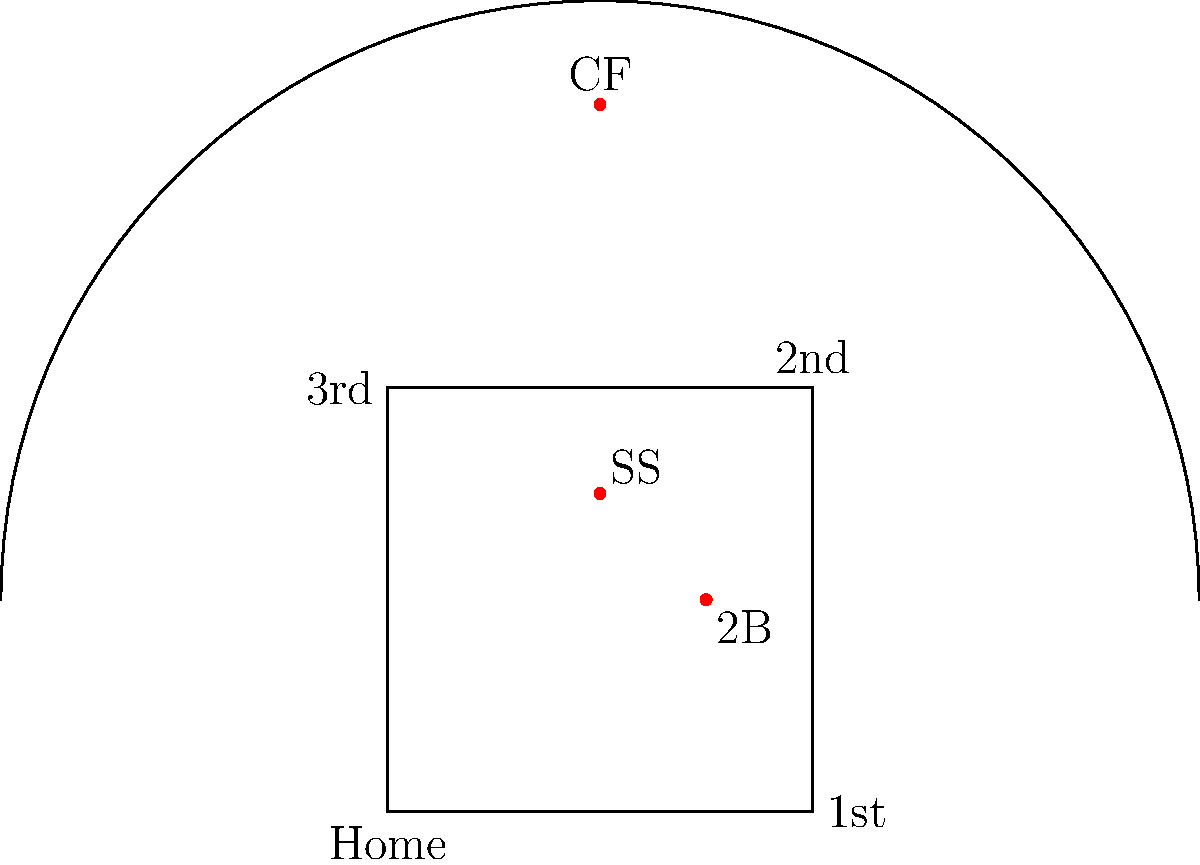Based on the baseball field diagram, which fielder position is best suited to cover the gap between second base and shortstop, while also providing support for shallow outfield plays? To answer this question, we need to analyze the positions of the fielders shown in the diagram and their strategic placement on the field:

1. The diagram shows three key defensive positions: shortstop (SS), second base (2B), and center field (CF).

2. The shortstop is positioned between second and third base, slightly closer to third.

3. The second baseman is positioned between first and second base, slightly closer to first.

4. The center fielder is positioned deep in the outfield, directly behind second base.

5. The gap between second base and shortstop is a common area for ground balls and line drives to pass through.

6. The second baseman (2B) is ideally positioned to cover this gap because:
   a) They are closer to the gap than the shortstop.
   b) They have a good angle to move towards shallow outfield if needed.
   c) Their position allows them to quickly shift between infield and shallow outfield play.

7. While the center fielder can support shallow outfield plays, they are too far back to effectively cover the gap between second and shortstop.

8. The shortstop, although close to the gap, is better positioned to cover the area between second and third base.

Therefore, the second baseman (2B) is best suited to cover the gap between second base and shortstop while also providing support for shallow outfield plays.
Answer: Second baseman (2B) 